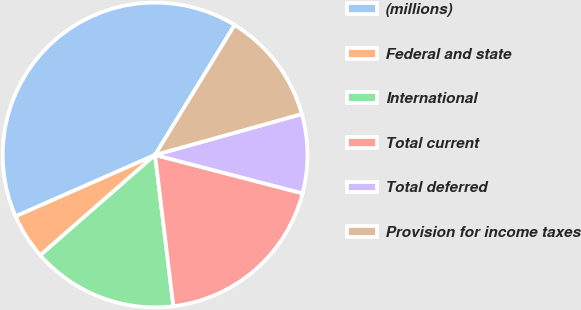<chart> <loc_0><loc_0><loc_500><loc_500><pie_chart><fcel>(millions)<fcel>Federal and state<fcel>International<fcel>Total current<fcel>Total deferred<fcel>Provision for income taxes<nl><fcel>40.34%<fcel>4.83%<fcel>15.48%<fcel>19.03%<fcel>8.38%<fcel>11.93%<nl></chart> 